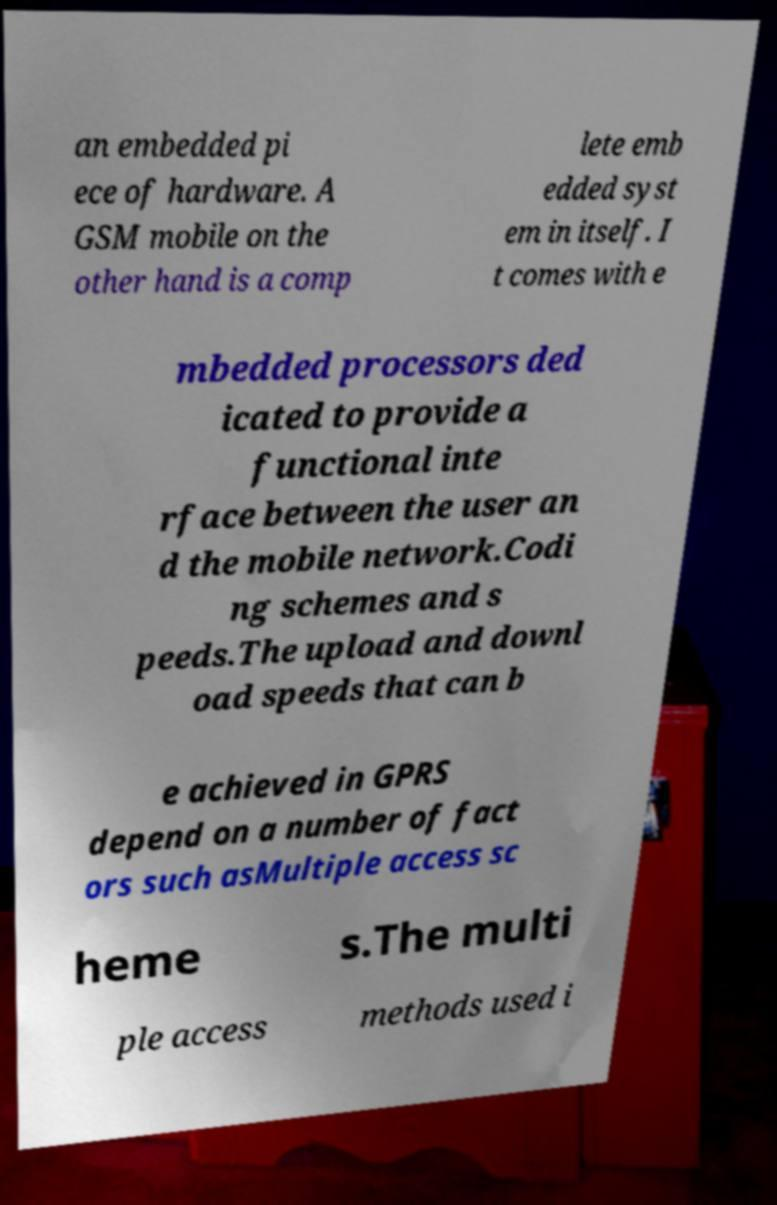Can you read and provide the text displayed in the image?This photo seems to have some interesting text. Can you extract and type it out for me? an embedded pi ece of hardware. A GSM mobile on the other hand is a comp lete emb edded syst em in itself. I t comes with e mbedded processors ded icated to provide a functional inte rface between the user an d the mobile network.Codi ng schemes and s peeds.The upload and downl oad speeds that can b e achieved in GPRS depend on a number of fact ors such asMultiple access sc heme s.The multi ple access methods used i 